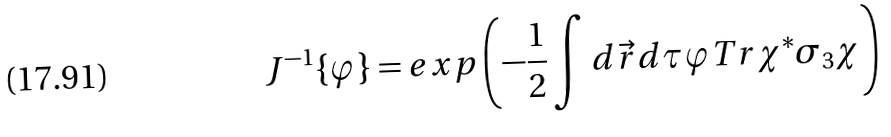<formula> <loc_0><loc_0><loc_500><loc_500>J ^ { - 1 } \{ \varphi \} = e x p \left ( - \frac { 1 } { 2 } \int d \vec { r } d \tau \varphi T r \chi ^ { \ast } \sigma _ { 3 } \chi \right )</formula> 